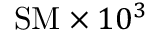<formula> <loc_0><loc_0><loc_500><loc_500>S M \times 1 0 ^ { 3 }</formula> 